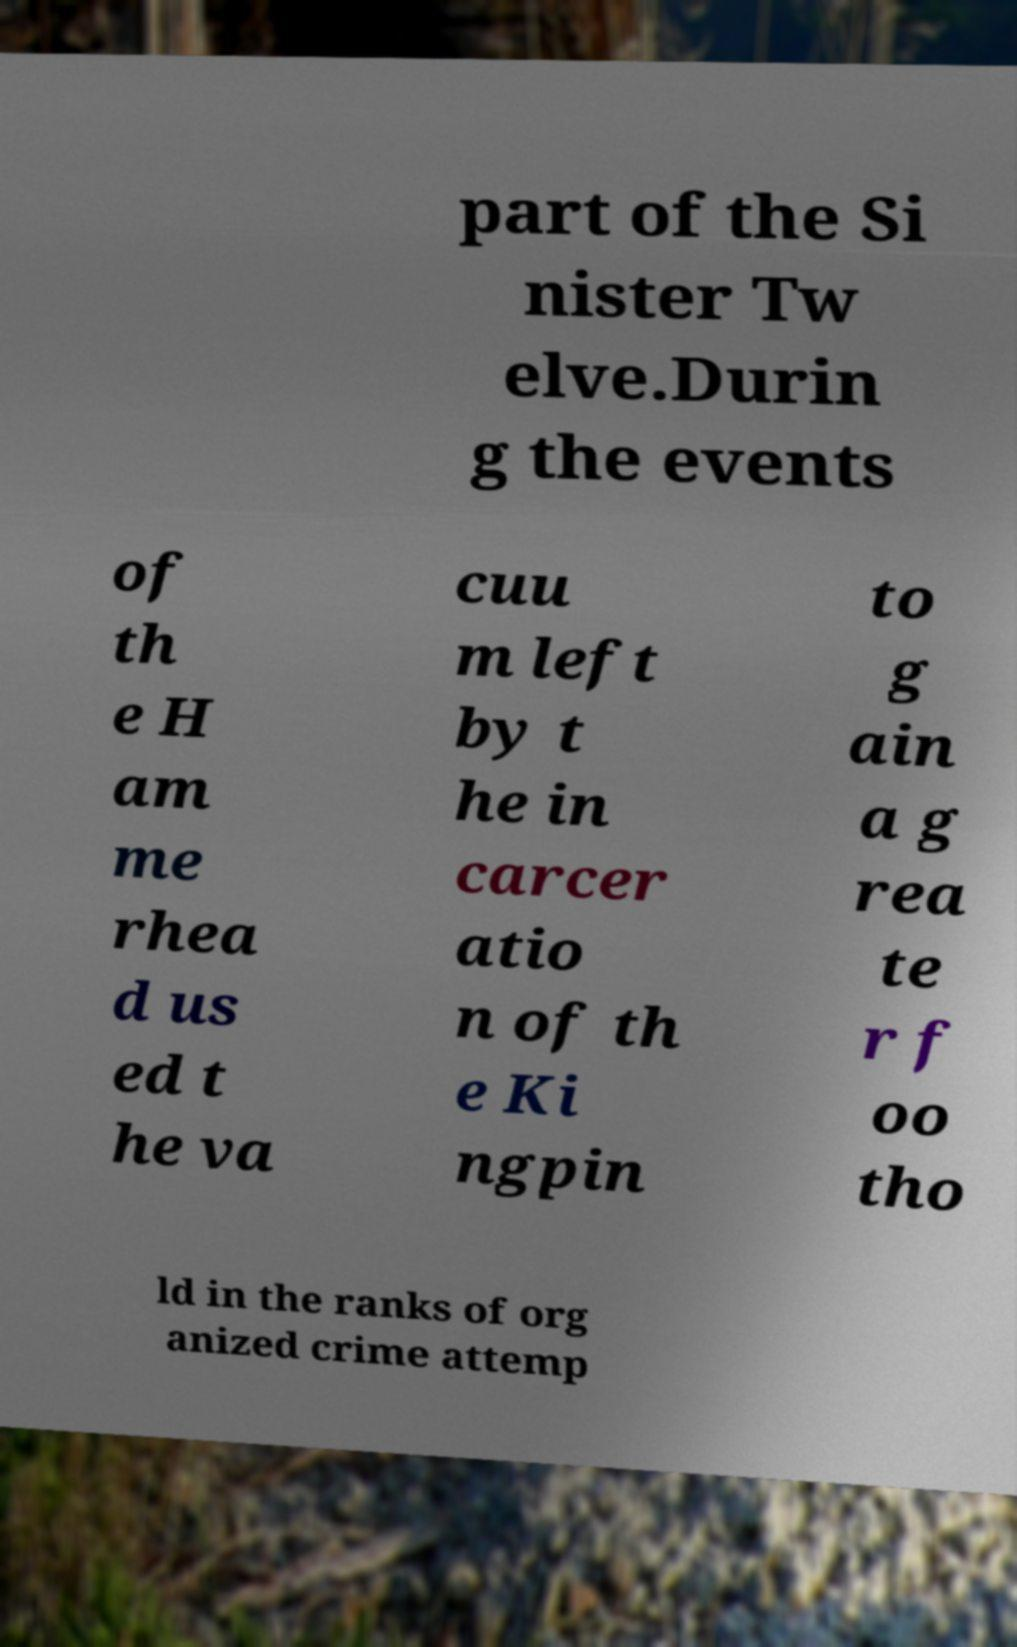Could you extract and type out the text from this image? part of the Si nister Tw elve.Durin g the events of th e H am me rhea d us ed t he va cuu m left by t he in carcer atio n of th e Ki ngpin to g ain a g rea te r f oo tho ld in the ranks of org anized crime attemp 